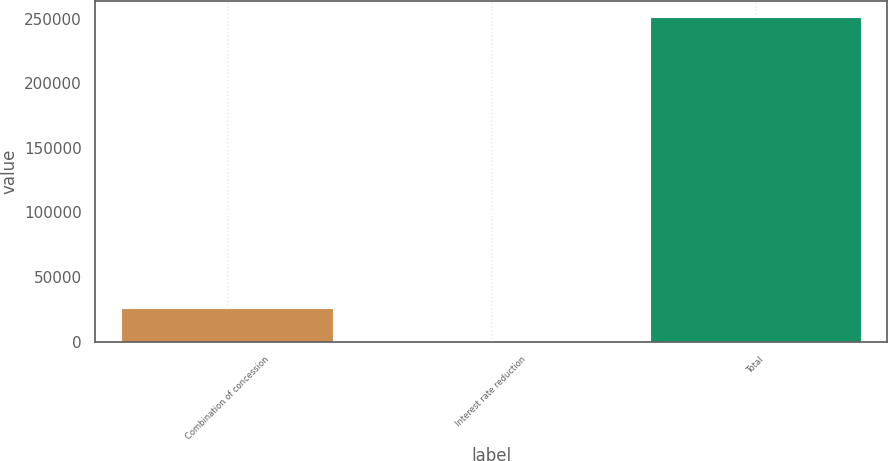Convert chart. <chart><loc_0><loc_0><loc_500><loc_500><bar_chart><fcel>Combination of concession<fcel>Interest rate reduction<fcel>Total<nl><fcel>25739<fcel>708<fcel>251018<nl></chart> 